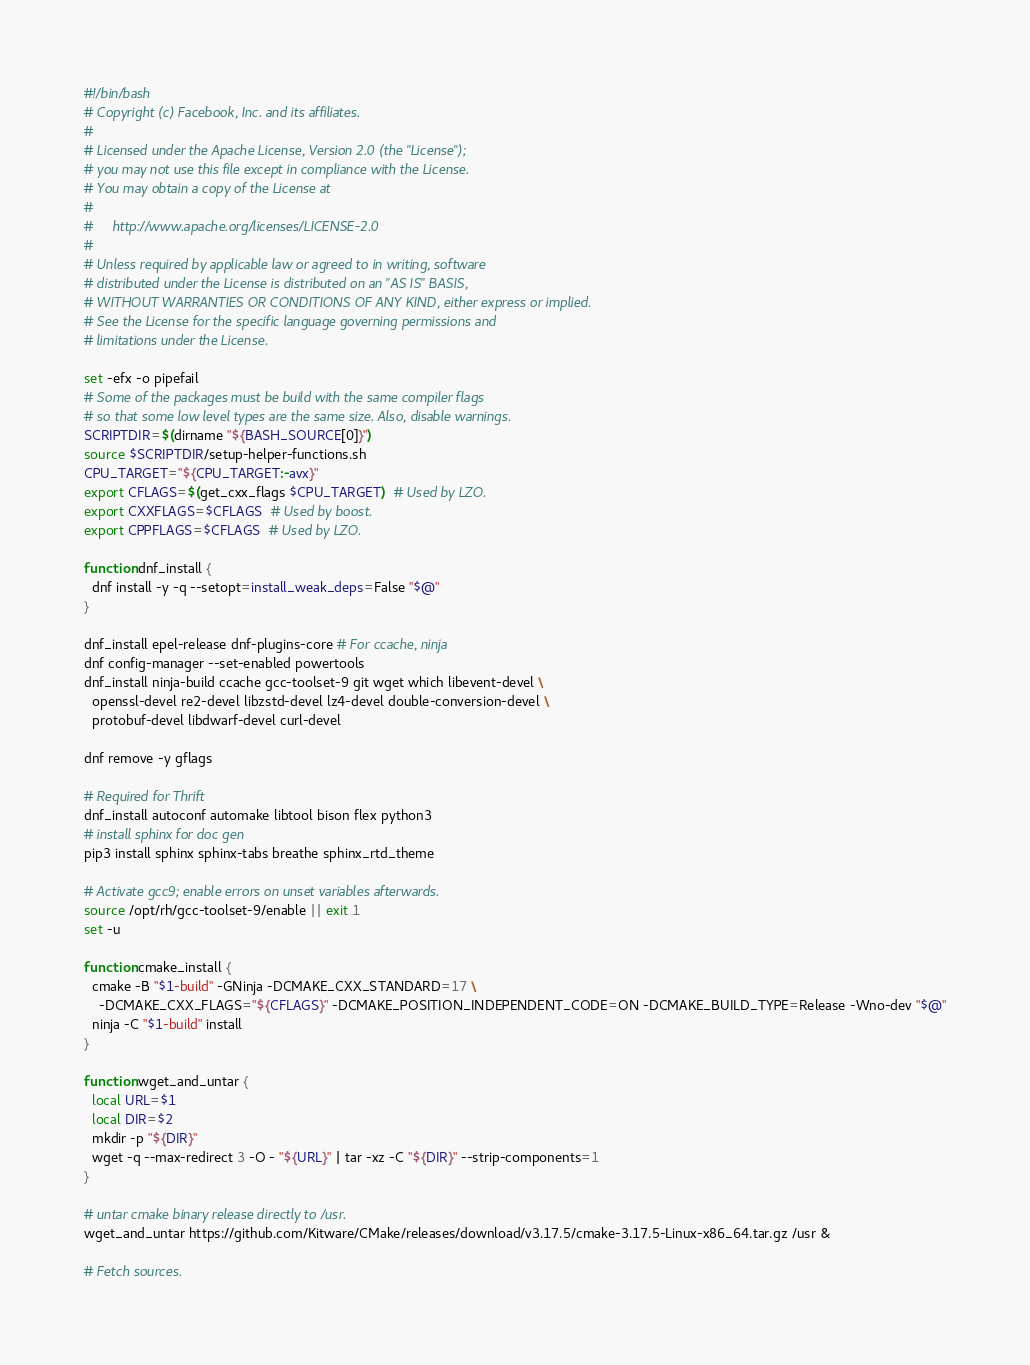<code> <loc_0><loc_0><loc_500><loc_500><_Bash_>#!/bin/bash
# Copyright (c) Facebook, Inc. and its affiliates.
#
# Licensed under the Apache License, Version 2.0 (the "License");
# you may not use this file except in compliance with the License.
# You may obtain a copy of the License at
#
#     http://www.apache.org/licenses/LICENSE-2.0
#
# Unless required by applicable law or agreed to in writing, software
# distributed under the License is distributed on an "AS IS" BASIS,
# WITHOUT WARRANTIES OR CONDITIONS OF ANY KIND, either express or implied.
# See the License for the specific language governing permissions and
# limitations under the License.

set -efx -o pipefail
# Some of the packages must be build with the same compiler flags
# so that some low level types are the same size. Also, disable warnings.
SCRIPTDIR=$(dirname "${BASH_SOURCE[0]}")
source $SCRIPTDIR/setup-helper-functions.sh
CPU_TARGET="${CPU_TARGET:-avx}"
export CFLAGS=$(get_cxx_flags $CPU_TARGET)  # Used by LZO.
export CXXFLAGS=$CFLAGS  # Used by boost.
export CPPFLAGS=$CFLAGS  # Used by LZO.

function dnf_install {
  dnf install -y -q --setopt=install_weak_deps=False "$@"
}

dnf_install epel-release dnf-plugins-core # For ccache, ninja
dnf config-manager --set-enabled powertools
dnf_install ninja-build ccache gcc-toolset-9 git wget which libevent-devel \
  openssl-devel re2-devel libzstd-devel lz4-devel double-conversion-devel \
  protobuf-devel libdwarf-devel curl-devel

dnf remove -y gflags

# Required for Thrift
dnf_install autoconf automake libtool bison flex python3
# install sphinx for doc gen
pip3 install sphinx sphinx-tabs breathe sphinx_rtd_theme

# Activate gcc9; enable errors on unset variables afterwards.
source /opt/rh/gcc-toolset-9/enable || exit 1
set -u

function cmake_install {
  cmake -B "$1-build" -GNinja -DCMAKE_CXX_STANDARD=17 \
    -DCMAKE_CXX_FLAGS="${CFLAGS}" -DCMAKE_POSITION_INDEPENDENT_CODE=ON -DCMAKE_BUILD_TYPE=Release -Wno-dev "$@"
  ninja -C "$1-build" install
}

function wget_and_untar {
  local URL=$1
  local DIR=$2
  mkdir -p "${DIR}"
  wget -q --max-redirect 3 -O - "${URL}" | tar -xz -C "${DIR}" --strip-components=1
}

# untar cmake binary release directly to /usr.
wget_and_untar https://github.com/Kitware/CMake/releases/download/v3.17.5/cmake-3.17.5-Linux-x86_64.tar.gz /usr &

# Fetch sources.</code> 